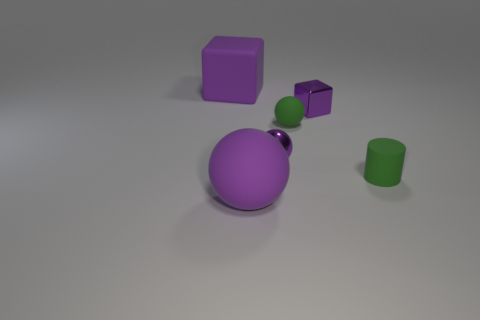Add 1 big purple matte objects. How many objects exist? 7 Subtract all cubes. How many objects are left? 4 Add 6 green things. How many green things are left? 8 Add 4 tiny blue matte cubes. How many tiny blue matte cubes exist? 4 Subtract 0 red blocks. How many objects are left? 6 Subtract all shiny things. Subtract all tiny purple metallic blocks. How many objects are left? 3 